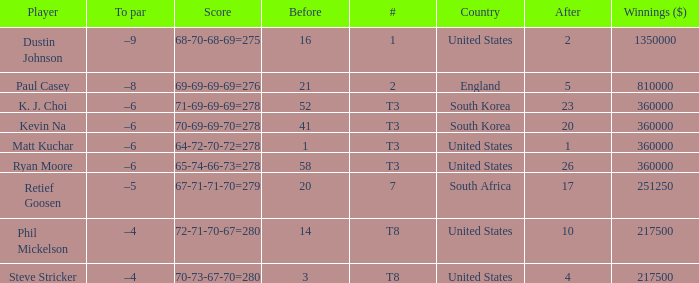Write the full table. {'header': ['Player', 'To par', 'Score', 'Before', '#', 'Country', 'After', 'Winnings ($)'], 'rows': [['Dustin Johnson', '–9', '68-70-68-69=275', '16', '1', 'United States', '2', '1350000'], ['Paul Casey', '–8', '69-69-69-69=276', '21', '2', 'England', '5', '810000'], ['K. J. Choi', '–6', '71-69-69-69=278', '52', 'T3', 'South Korea', '23', '360000'], ['Kevin Na', '–6', '70-69-69-70=278', '41', 'T3', 'South Korea', '20', '360000'], ['Matt Kuchar', '–6', '64-72-70-72=278', '1', 'T3', 'United States', '1', '360000'], ['Ryan Moore', '–6', '65-74-66-73=278', '58', 'T3', 'United States', '26', '360000'], ['Retief Goosen', '–5', '67-71-71-70=279', '20', '7', 'South Africa', '17', '251250'], ['Phil Mickelson', '–4', '72-71-70-67=280', '14', 'T8', 'United States', '10', '217500'], ['Steve Stricker', '–4', '70-73-67-70=280', '3', 'T8', 'United States', '4', '217500']]} What is the # listed when the score is 70-69-69-70=278? T3. 